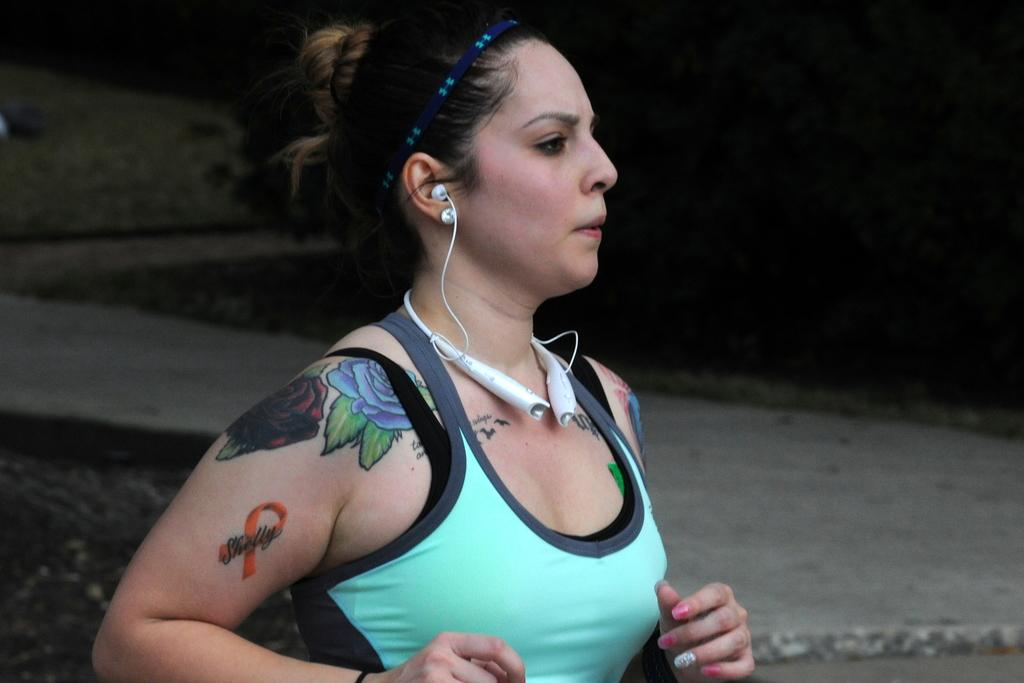Who is the main subject in the image? There is a girl in the image. What is the girl doing in the image? The girl is running. What is the girl wearing that is related to technology? The girl is wearing a Bluetooth headset. What is the color of the background in the image? The background of the image is black. How many pies can be seen on the girl's head in the image? There are no pies present in the image, and the girl is not wearing any on her head. What type of bun is the girl holding in the image? There is no bun present in the image, and the girl is not holding one. 